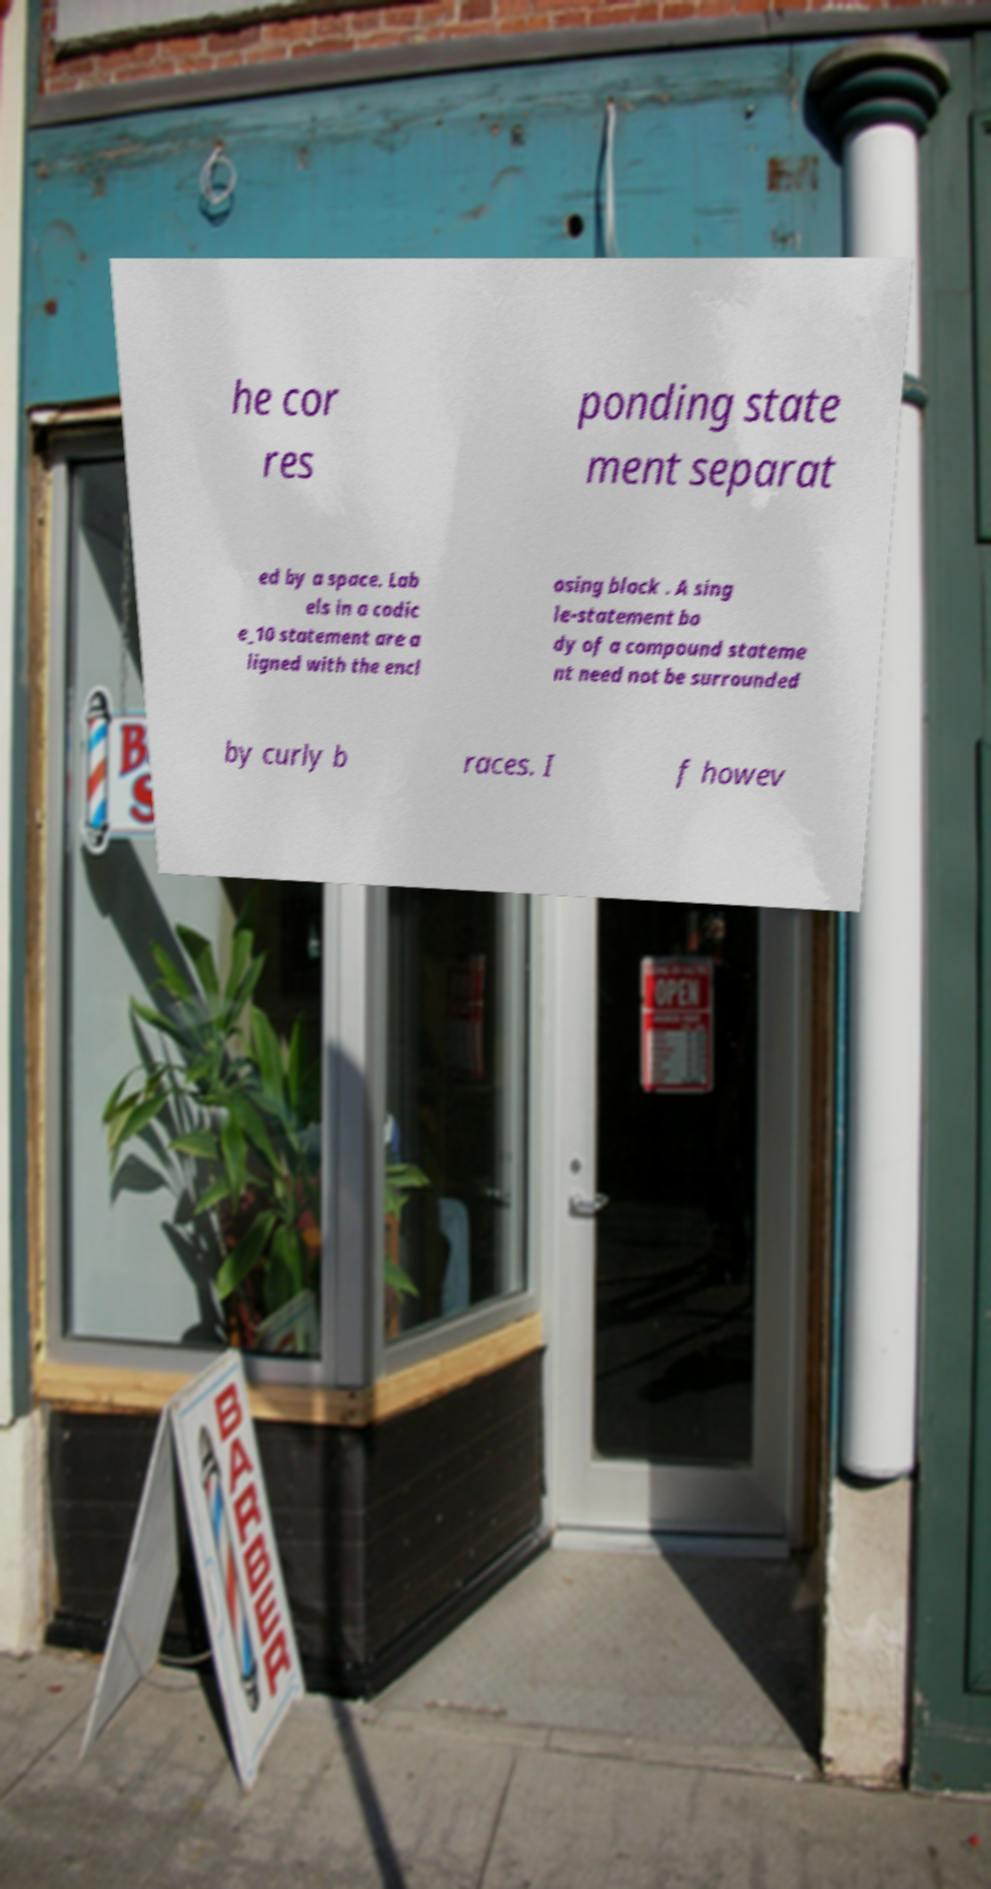Can you accurately transcribe the text from the provided image for me? he cor res ponding state ment separat ed by a space. Lab els in a codic e_10 statement are a ligned with the encl osing block . A sing le-statement bo dy of a compound stateme nt need not be surrounded by curly b races. I f howev 